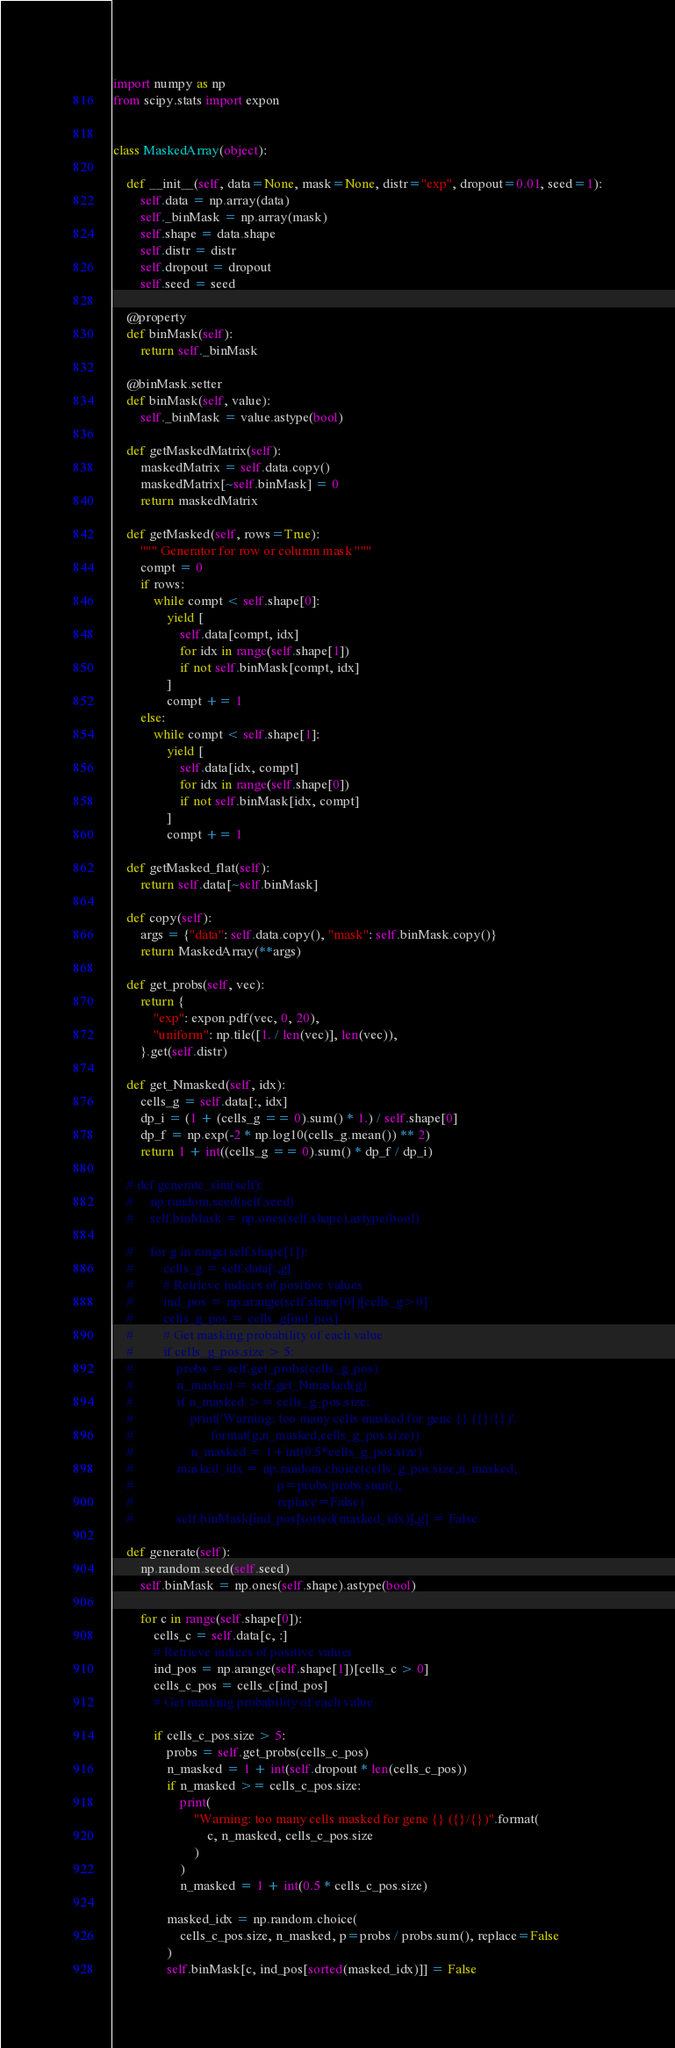<code> <loc_0><loc_0><loc_500><loc_500><_Python_>import numpy as np
from scipy.stats import expon


class MaskedArray(object):

    def __init__(self, data=None, mask=None, distr="exp", dropout=0.01, seed=1):
        self.data = np.array(data)
        self._binMask = np.array(mask)
        self.shape = data.shape
        self.distr = distr
        self.dropout = dropout
        self.seed = seed

    @property
    def binMask(self):
        return self._binMask

    @binMask.setter
    def binMask(self, value):
        self._binMask = value.astype(bool)

    def getMaskedMatrix(self):
        maskedMatrix = self.data.copy()
        maskedMatrix[~self.binMask] = 0
        return maskedMatrix

    def getMasked(self, rows=True):
        """ Generator for row or column mask """
        compt = 0
        if rows:
            while compt < self.shape[0]:
                yield [
                    self.data[compt, idx]
                    for idx in range(self.shape[1])
                    if not self.binMask[compt, idx]
                ]
                compt += 1
        else:
            while compt < self.shape[1]:
                yield [
                    self.data[idx, compt]
                    for idx in range(self.shape[0])
                    if not self.binMask[idx, compt]
                ]
                compt += 1

    def getMasked_flat(self):
        return self.data[~self.binMask]

    def copy(self):
        args = {"data": self.data.copy(), "mask": self.binMask.copy()}
        return MaskedArray(**args)

    def get_probs(self, vec):
        return {
            "exp": expon.pdf(vec, 0, 20),
            "uniform": np.tile([1. / len(vec)], len(vec)),
        }.get(self.distr)

    def get_Nmasked(self, idx):
        cells_g = self.data[:, idx]
        dp_i = (1 + (cells_g == 0).sum() * 1.) / self.shape[0]
        dp_f = np.exp(-2 * np.log10(cells_g.mean()) ** 2)
        return 1 + int((cells_g == 0).sum() * dp_f / dp_i)

    # def generate_sim(self):
    #     np.random.seed(self.seed)
    #     self.binMask = np.ones(self.shape).astype(bool)

    #     for g in range(self.shape[1]):
    #         cells_g = self.data[:,g]
    #         # Retrieve indices of positive values
    #         ind_pos = np.arange(self.shape[0])[cells_g>0]
    #         cells_g_pos = cells_g[ind_pos]
    #         # Get masking probability of each value
    #         if cells_g_pos.size > 5:
    #             probs = self.get_probs(cells_g_pos)
    #             n_masked = self.get_Nmasked(g)
    #             if n_masked >= cells_g_pos.size:
    #                 print('Warning: too many cells masked for gene {} ({}/{})'.
    #                       format(g,n_masked,cells_g_pos.size))
    #                 n_masked = 1+int(0.5*cells_g_pos.size)
    #             masked_idx = np.random.choice(cells_g_pos.size,n_masked,
    #                                           p=probs/probs.sum(),
    #                                           replace=False)
    #             self.binMask[ind_pos[sorted(masked_idx)],g] = False

    def generate(self):
        np.random.seed(self.seed)
        self.binMask = np.ones(self.shape).astype(bool)

        for c in range(self.shape[0]):
            cells_c = self.data[c, :]
            # Retrieve indices of positive values
            ind_pos = np.arange(self.shape[1])[cells_c > 0]
            cells_c_pos = cells_c[ind_pos]
            # Get masking probability of each value

            if cells_c_pos.size > 5:
                probs = self.get_probs(cells_c_pos)
                n_masked = 1 + int(self.dropout * len(cells_c_pos))
                if n_masked >= cells_c_pos.size:
                    print(
                        "Warning: too many cells masked for gene {} ({}/{})".format(
                            c, n_masked, cells_c_pos.size
                        )
                    )
                    n_masked = 1 + int(0.5 * cells_c_pos.size)

                masked_idx = np.random.choice(
                    cells_c_pos.size, n_masked, p=probs / probs.sum(), replace=False
                )
                self.binMask[c, ind_pos[sorted(masked_idx)]] = False
</code> 